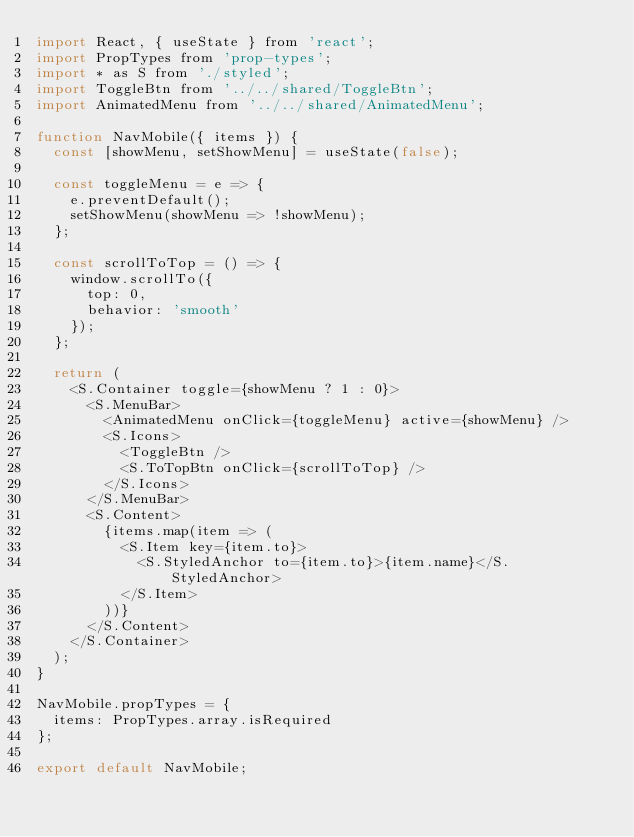<code> <loc_0><loc_0><loc_500><loc_500><_JavaScript_>import React, { useState } from 'react';
import PropTypes from 'prop-types';
import * as S from './styled';
import ToggleBtn from '../../shared/ToggleBtn';
import AnimatedMenu from '../../shared/AnimatedMenu';

function NavMobile({ items }) {
  const [showMenu, setShowMenu] = useState(false);

  const toggleMenu = e => {
    e.preventDefault();
    setShowMenu(showMenu => !showMenu);
  };

  const scrollToTop = () => {
    window.scrollTo({
      top: 0,
      behavior: 'smooth'
    });
  };

  return (
    <S.Container toggle={showMenu ? 1 : 0}>
      <S.MenuBar>
        <AnimatedMenu onClick={toggleMenu} active={showMenu} />
        <S.Icons>
          <ToggleBtn />
          <S.ToTopBtn onClick={scrollToTop} />
        </S.Icons>
      </S.MenuBar>
      <S.Content>
        {items.map(item => (
          <S.Item key={item.to}>
            <S.StyledAnchor to={item.to}>{item.name}</S.StyledAnchor>
          </S.Item>
        ))}
      </S.Content>
    </S.Container>
  );
}

NavMobile.propTypes = {
  items: PropTypes.array.isRequired
};

export default NavMobile;
</code> 